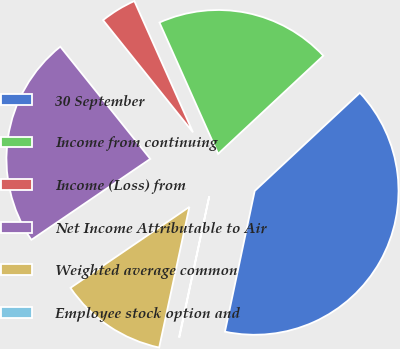<chart> <loc_0><loc_0><loc_500><loc_500><pie_chart><fcel>30 September<fcel>Income from continuing<fcel>Income (Loss) from<fcel>Net Income Attributable to Air<fcel>Weighted average common<fcel>Employee stock option and<nl><fcel>40.27%<fcel>19.74%<fcel>4.07%<fcel>23.76%<fcel>12.12%<fcel>0.05%<nl></chart> 